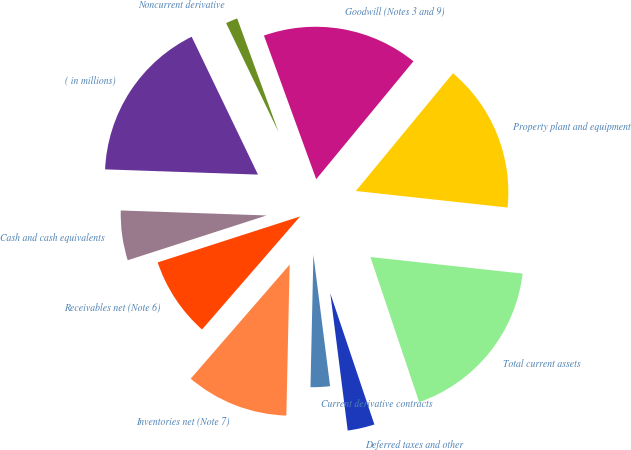Convert chart. <chart><loc_0><loc_0><loc_500><loc_500><pie_chart><fcel>( in millions)<fcel>Cash and cash equivalents<fcel>Receivables net (Note 6)<fcel>Inventories net (Note 7)<fcel>Current derivative contracts<fcel>Deferred taxes and other<fcel>Total current assets<fcel>Property plant and equipment<fcel>Goodwill (Notes 3 and 9)<fcel>Noncurrent derivative<nl><fcel>17.32%<fcel>5.51%<fcel>8.66%<fcel>11.02%<fcel>2.36%<fcel>3.15%<fcel>18.11%<fcel>15.75%<fcel>16.53%<fcel>1.58%<nl></chart> 